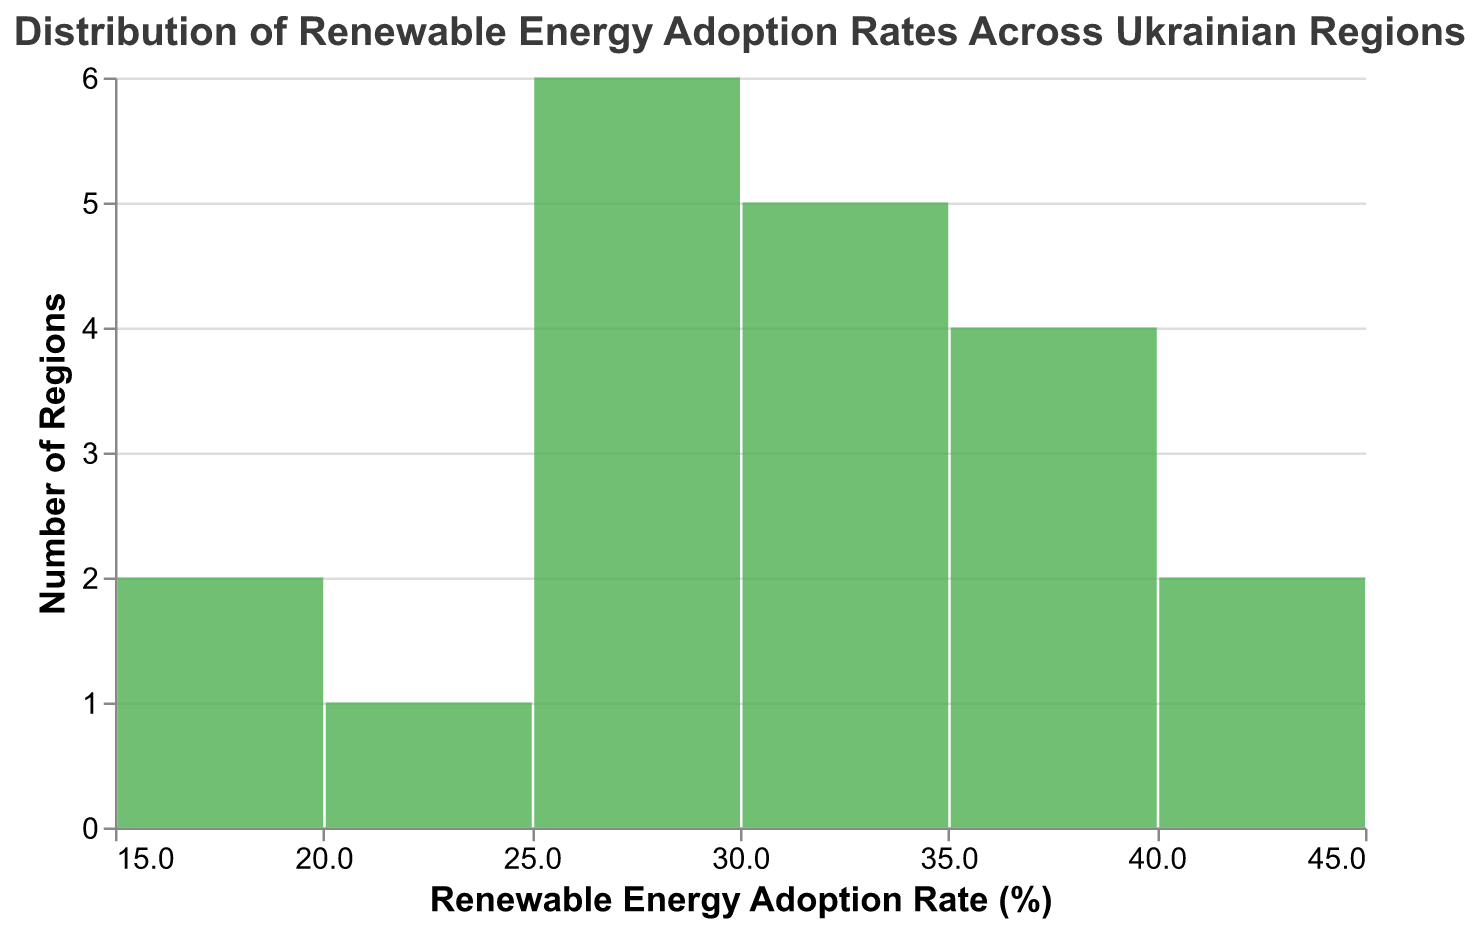What's the title of the plot? The title of the plot is visible at the top, indicating what the chart represents.
Answer: Distribution of Renewable Energy Adoption Rates Across Ukrainian Regions How many regions have renewable energy adoption rates between 30% and 39%? Identify the bar corresponding to the range of 30% to 39% on the x-axis and see the Y-axis value indicating the number of regions. The height of the bar around this range corresponds to the count of regions.
Answer: 8 Which region has the lowest renewable energy adoption rate? The individual data points reveal that Luhansk has the lowest renewable energy adoption rate at 15.2%.
Answer: Luhansk What is the renewable energy adoption rate for Rivne? By checking the data, Rivne’s rate corresponds to 42.6%, which is an outlier towards the higher end.
Answer: 42.6% How many regions have a renewable energy adoption rate of less than 20%? Examine the bars for adoption rates less than 20% to count the number of regions.
Answer: 2 What is the range of renewable energy adoption rates? Calculate by subtracting the minimum adoption rate (15.2%) from the maximum rate (42.6%).
Answer: 27.4% What's the most common range for renewable energy adoption rates? Look at which bar on the plot is highest, representing the range the most regions fall into.
Answer: 30% to 39% How many regions have a renewable energy adoption rate greater than or equal to 35%? Identify the bars to the right of 35% and sum their counts.
Answer: 7 Which region has an adoption rate closest to the median of all listed regions? Arrange the data in ascending order and find the middle value to determine the median. Sumy, with an adoption rate of 29.1%, is closest to the median.
Answer: Sumy Which regions have adoption rates that exceed the average value of all regions? First, find the average by summing all rates and dividing by the number of regions. Then, identify regions with rates above this average.
Answer: Kyiv, Lviv, Ivano-Frankivsk, Rivne, Chernihiv, Mykolaiv, Kherson, Chernivtsi 